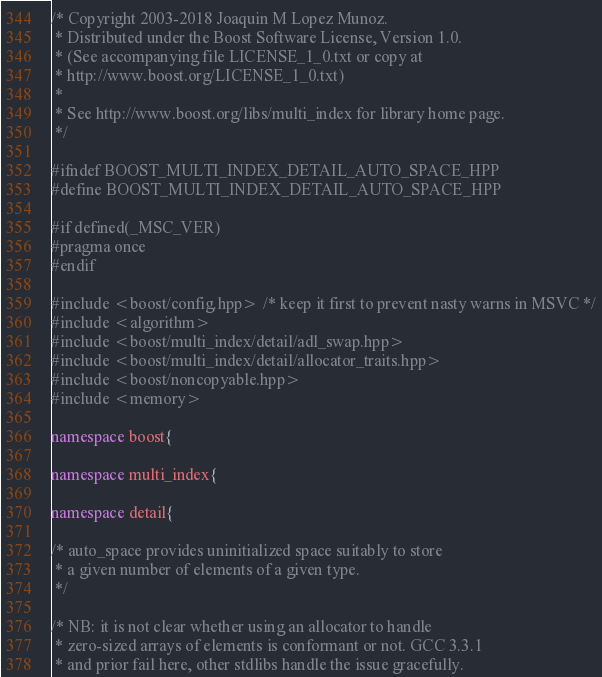<code> <loc_0><loc_0><loc_500><loc_500><_C++_>/* Copyright 2003-2018 Joaquin M Lopez Munoz.
 * Distributed under the Boost Software License, Version 1.0.
 * (See accompanying file LICENSE_1_0.txt or copy at
 * http://www.boost.org/LICENSE_1_0.txt)
 *
 * See http://www.boost.org/libs/multi_index for library home page.
 */

#ifndef BOOST_MULTI_INDEX_DETAIL_AUTO_SPACE_HPP
#define BOOST_MULTI_INDEX_DETAIL_AUTO_SPACE_HPP

#if defined(_MSC_VER)
#pragma once
#endif

#include <boost/config.hpp> /* keep it first to prevent nasty warns in MSVC */
#include <algorithm>
#include <boost/multi_index/detail/adl_swap.hpp>
#include <boost/multi_index/detail/allocator_traits.hpp>
#include <boost/noncopyable.hpp>
#include <memory>

namespace boost{

namespace multi_index{

namespace detail{

/* auto_space provides uninitialized space suitably to store
 * a given number of elements of a given type.
 */

/* NB: it is not clear whether using an allocator to handle
 * zero-sized arrays of elements is conformant or not. GCC 3.3.1
 * and prior fail here, other stdlibs handle the issue gracefully.</code> 